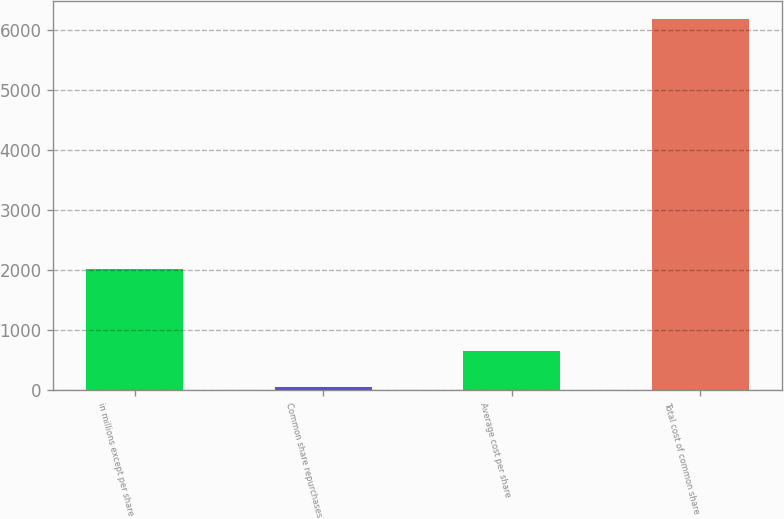<chart> <loc_0><loc_0><loc_500><loc_500><bar_chart><fcel>in millions except per share<fcel>Common share repurchases<fcel>Average cost per share<fcel>Total cost of common share<nl><fcel>2013<fcel>39.3<fcel>652.87<fcel>6175<nl></chart> 